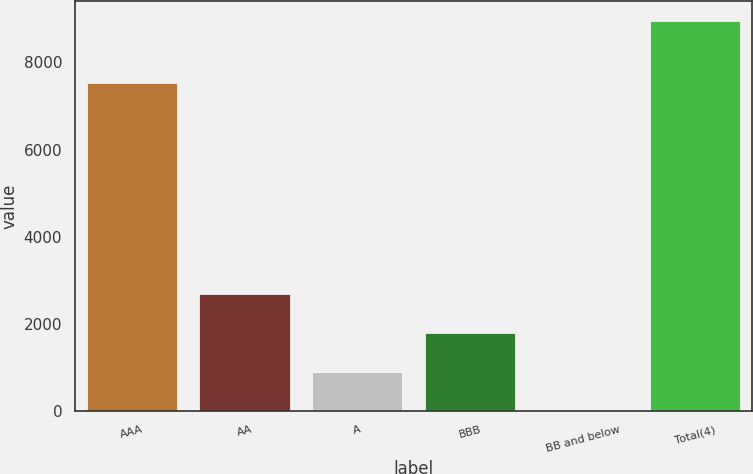Convert chart to OTSL. <chart><loc_0><loc_0><loc_500><loc_500><bar_chart><fcel>AAA<fcel>AA<fcel>A<fcel>BBB<fcel>BB and below<fcel>Total(4)<nl><fcel>7523<fcel>2686.78<fcel>896.42<fcel>1791.6<fcel>1.24<fcel>8953<nl></chart> 